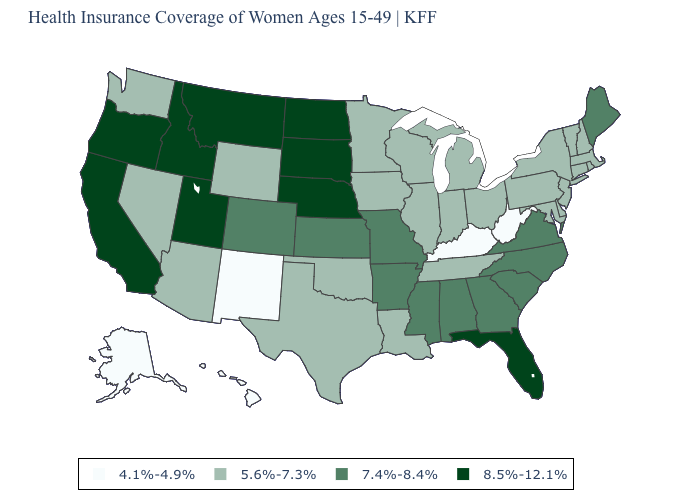Is the legend a continuous bar?
Write a very short answer. No. Does Hawaii have the lowest value in the USA?
Quick response, please. Yes. Which states have the highest value in the USA?
Quick response, please. California, Florida, Idaho, Montana, Nebraska, North Dakota, Oregon, South Dakota, Utah. What is the value of Connecticut?
Answer briefly. 5.6%-7.3%. What is the lowest value in states that border Alabama?
Concise answer only. 5.6%-7.3%. What is the value of Wyoming?
Write a very short answer. 5.6%-7.3%. Name the states that have a value in the range 7.4%-8.4%?
Write a very short answer. Alabama, Arkansas, Colorado, Georgia, Kansas, Maine, Mississippi, Missouri, North Carolina, South Carolina, Virginia. What is the value of Florida?
Quick response, please. 8.5%-12.1%. What is the highest value in the USA?
Quick response, please. 8.5%-12.1%. What is the value of North Carolina?
Quick response, please. 7.4%-8.4%. Name the states that have a value in the range 8.5%-12.1%?
Concise answer only. California, Florida, Idaho, Montana, Nebraska, North Dakota, Oregon, South Dakota, Utah. What is the value of Nebraska?
Answer briefly. 8.5%-12.1%. What is the highest value in states that border Minnesota?
Short answer required. 8.5%-12.1%. What is the lowest value in states that border New Hampshire?
Short answer required. 5.6%-7.3%. Among the states that border Colorado , which have the lowest value?
Keep it brief. New Mexico. 